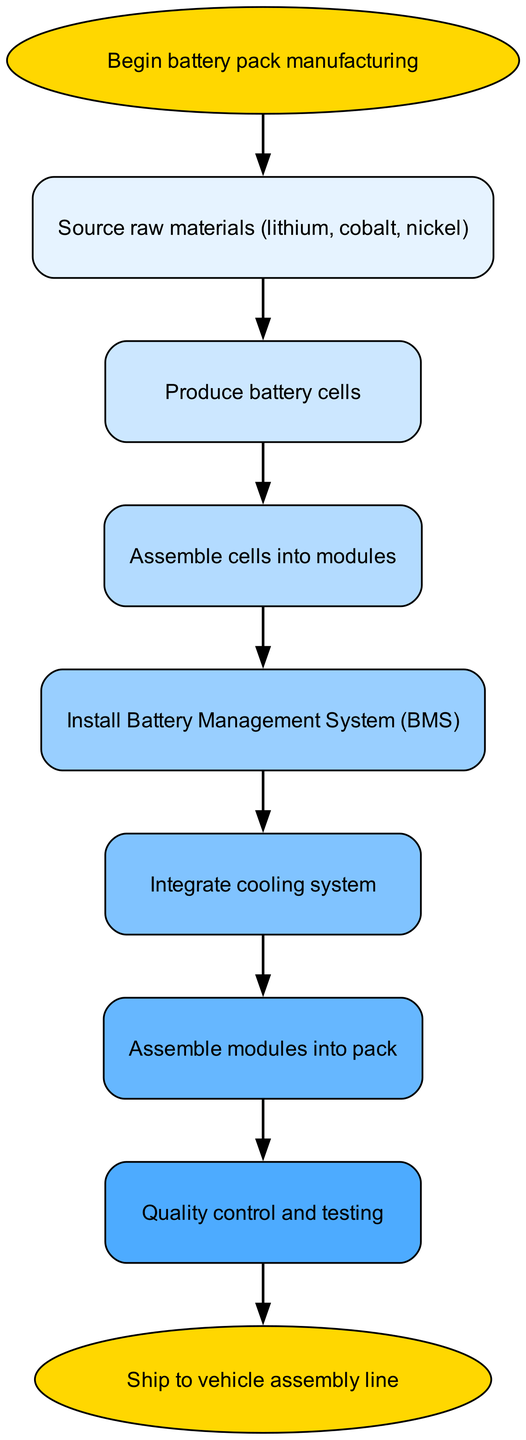What is the first step in the battery pack manufacturing process? The diagram starts with the node labeled "Begin battery pack manufacturing", which is followed by sourcing raw materials. Therefore, the first step is to source raw materials.
Answer: Source raw materials (lithium, cobalt, nickel) How many total steps are in the manufacturing process? The diagram consists of eight nodes: one start node, six process nodes, and one end node. Counting these nodes gives a total of eight steps in the manufacturing process.
Answer: Eight What node comes directly after producing battery cells? In the diagram, the node following "Produce battery cells" is "Assemble cells into modules". Therefore, the next step after producing battery cells is to assemble cells into modules.
Answer: Assemble cells into modules Which step involves the installation of a critical management system? The diagram indicates that after assembling cells into modules, the next step is to "Install Battery Management System (BMS)", highlighting that this step is crucial for managing the battery's performance.
Answer: Install Battery Management System (BMS) What do you do after quality control and testing? Following the "Quality control and testing" node in the diagram, the next step is to "Ship to vehicle assembly line". This indicates that shipping occurs immediately after quality testing.
Answer: Ship to vehicle assembly line What is the last step in the manufacturing process? The final node in the diagram, which follows all previous steps, is labeled "Ship to vehicle assembly line", indicating that this is the last step in the manufacturing process.
Answer: Ship to vehicle assembly line Which step comes before integrating the cooling system? In the diagram, the step that precedes "Integrate cooling system" is "Install Battery Management System (BMS)". Therefore, integrating the cooling system follows the installation of the BMS.
Answer: Install Battery Management System (BMS) How does the process flow from producing battery cells to assembling modules? According to the diagram, after "Produce battery cells," the next step, linked directly, is "Assemble cells into modules". This means that the process flows from producing cells directly to assembling them into modules without any other intervening steps.
Answer: Assemble cells into modules At which point in the process is quality control conducted? The diagram specifies that "Quality control and testing" occurs after "Assemble modules into pack", indicating this testing phase takes place before the final shipping step.
Answer: After assembling modules into pack 